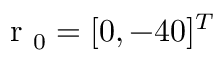Convert formula to latex. <formula><loc_0><loc_0><loc_500><loc_500>r _ { 0 } = [ 0 , - 4 0 ] ^ { T }</formula> 